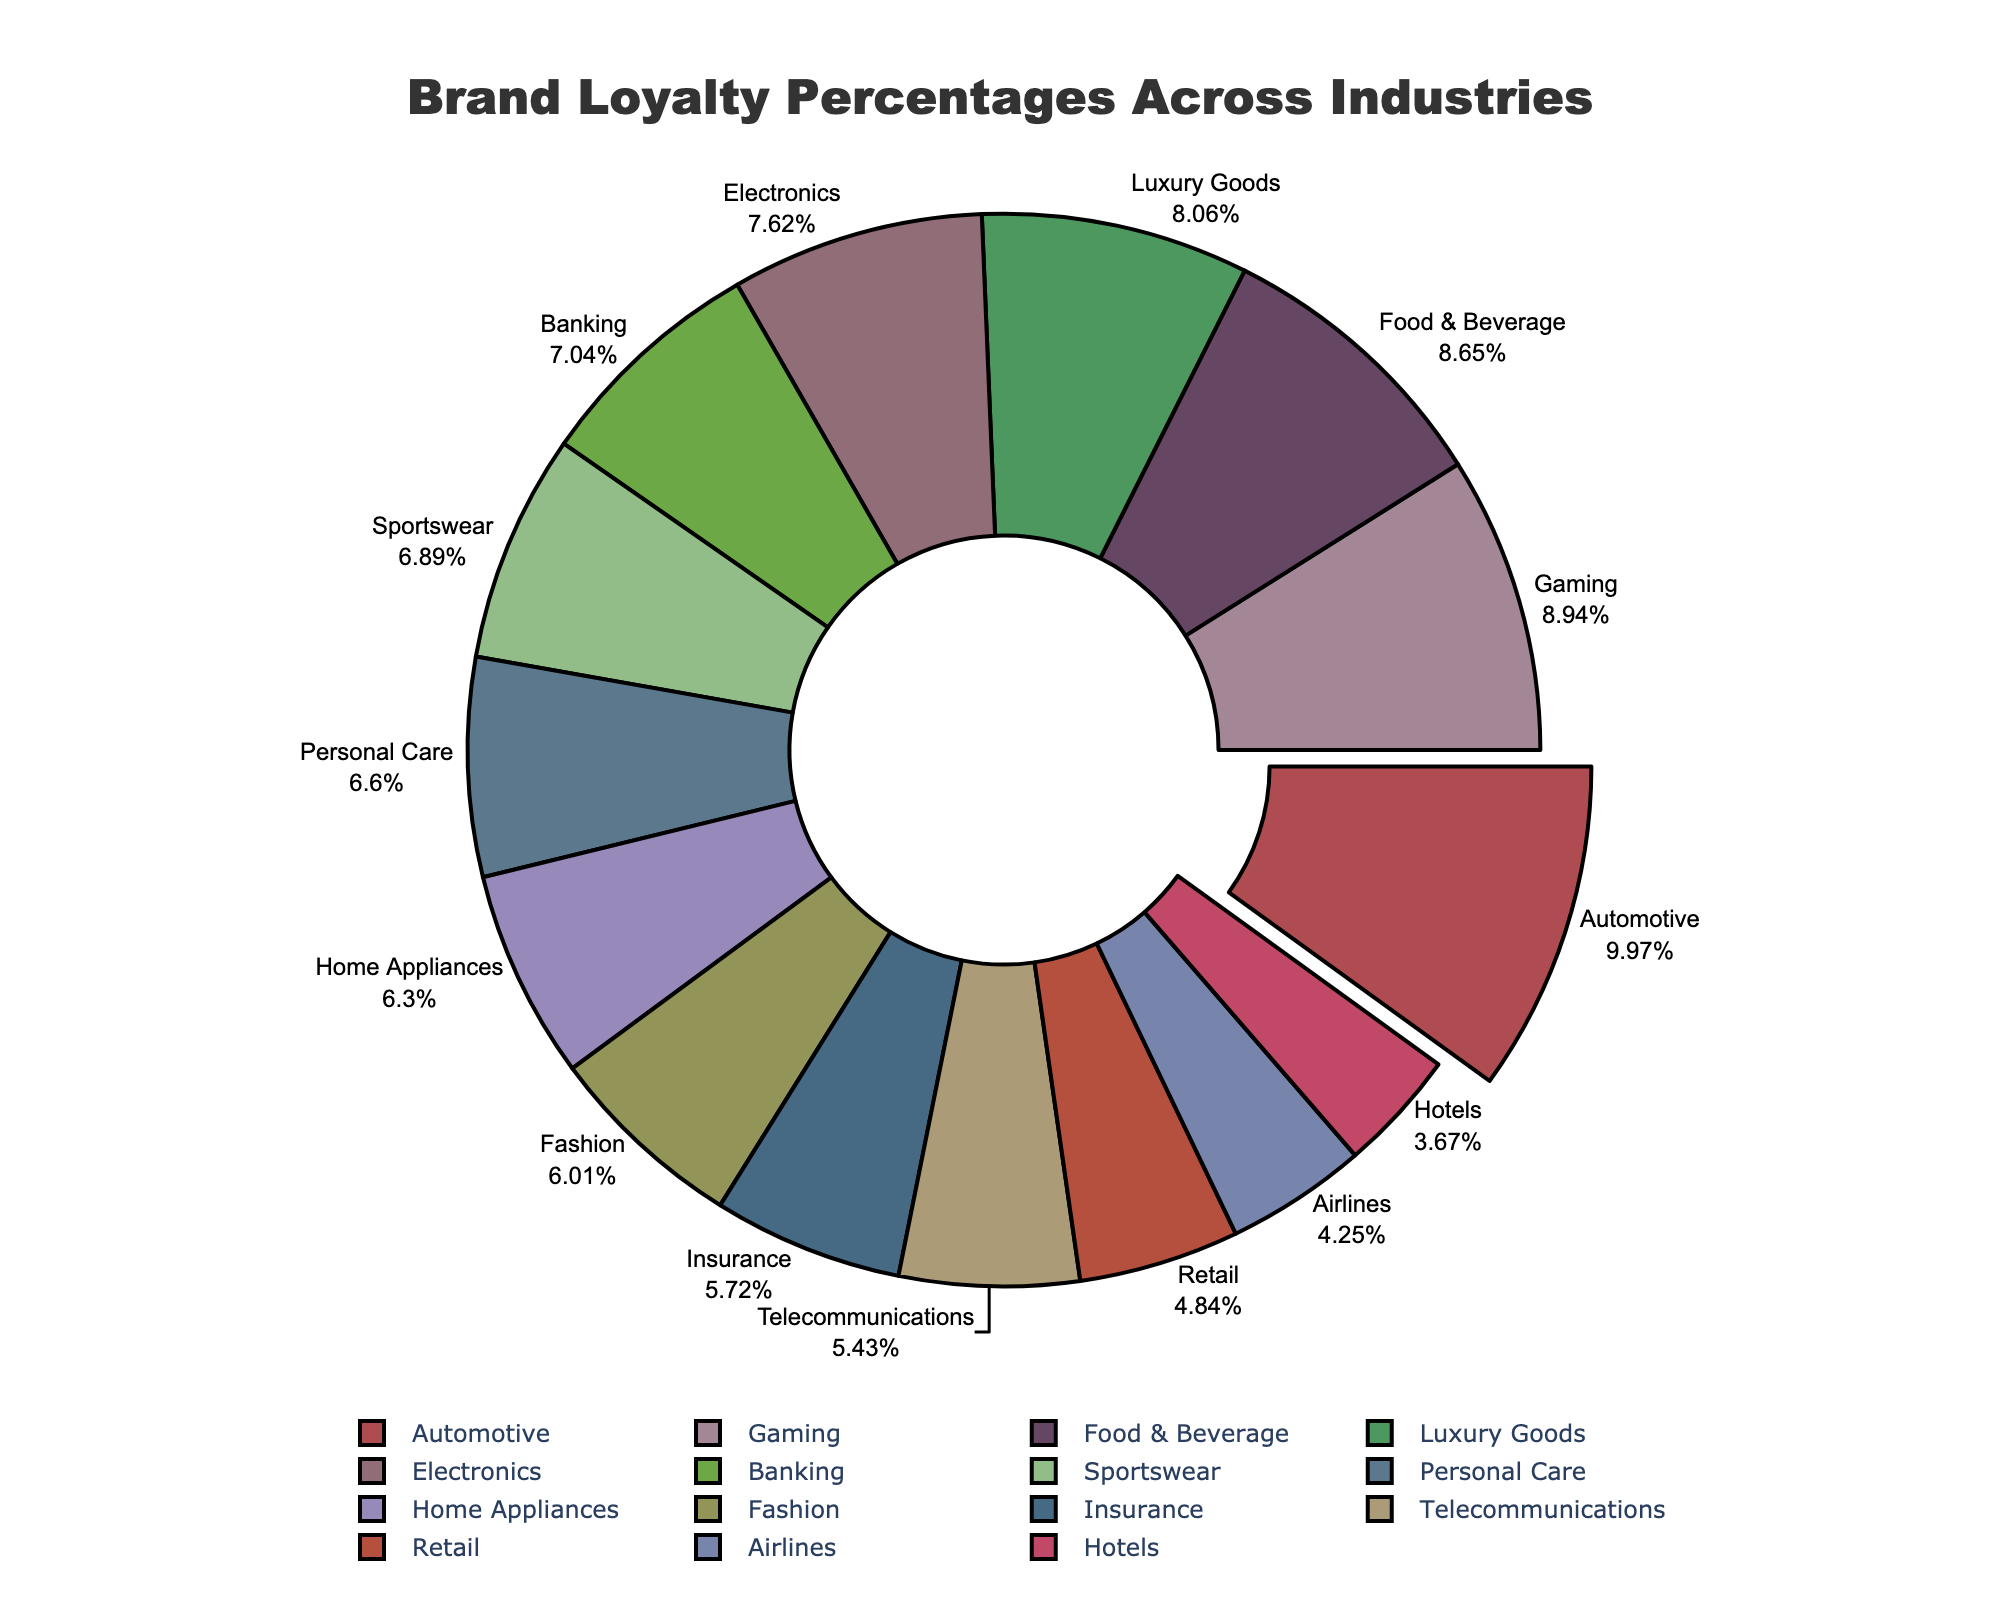What industry has the highest brand loyalty percentage? By looking at the chart, the segment pulled slightly away from the pie and labeled "Automotive" has the highest percentage.
Answer: Automotive Which two industries have the closest brand loyalty percentages? Observing the chart, "Insurance" at 39% and "Telecommunications" at 37% are the closest in percentage.
Answer: Insurance and Telecommunications What is the combined brand loyalty percentage of the top three industries? The top three industries are Automotive (68%), Gaming (61%), and Food & Beverage (59%). Their combined percentage is \( 68 + 61 + 59 = 188 \).
Answer: 188% How does brand loyalty in the Fashion industry compare to the Home Appliances industry? Fashion has a brand loyalty percentage of 41%, and Home Appliances has 43%. Therefore, Home Appliances has a slightly higher brand loyalty than Fashion.
Answer: Home Appliances has higher loyalty What is the average brand loyalty percentage among the Fashion, Personal Care, and Sportswear industries? The percentages are Fashion (41%), Personal Care (45%), and Sportswear (47%). The average is \( \frac{41 + 45 + 47}{3} = \frac{133}{3} = 44.33 \).
Answer: 44.33% Which industry has a higher brand loyalty percentage: Electronics or Luxury Goods? By observing the chart, Electronics has 52% while Luxury Goods has 55%, thus Luxury Goods has a higher brand loyalty percentage.
Answer: Luxury Goods Rank the industries with brand loyalty percentages greater than 50%. The industries with percentages greater than 50% are Automotive (68%), Gaming (61%), Food & Beverage (59%), Luxury Goods (55%), and Electronics (52%). Ranking them from highest to lowest: Automotive, Gaming, Food & Beverage, Luxury Goods, Electronics.
Answer: Automotive, Gaming, Food & Beverage, Luxury Goods, Electronics What is the difference in brand loyalty percentage between the Retail and Hotels industries? Retail's percentage is 33% and Hotels' is 25%, so the difference is \( 33 - 25 = 8 \).
Answer: 8% What percentage of brand loyalty is represented by industries with loyalty below 40%? The industries below 40% are Telecommunications (37%), Retail (33%), Airlines (29%), and Hotels (25%). The combined percentage is \( 37 + 33 + 29 + 25 = 124 \).
Answer: 124% 